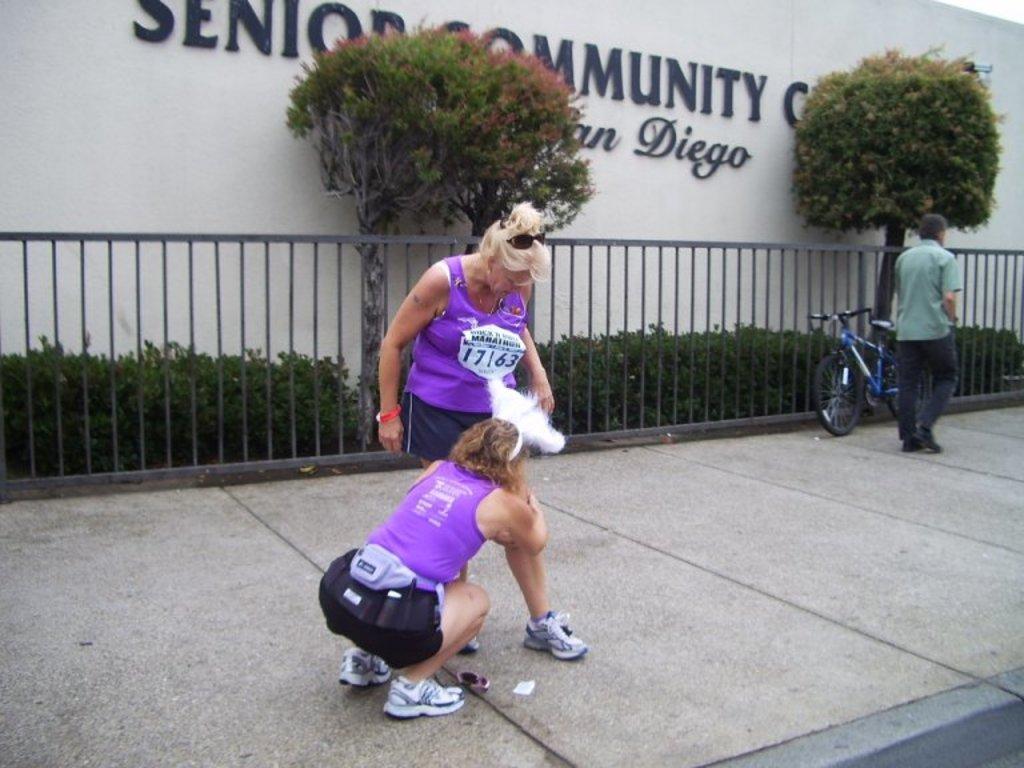In one or two sentences, can you explain what this image depicts? In this picture we can see a woman holding a leg of another woman. We can see a bicycle and a person on the right side. There is some fencing. Behind this fencing, we can see a few plants and trees. There is some text visible on a wall in the background. 